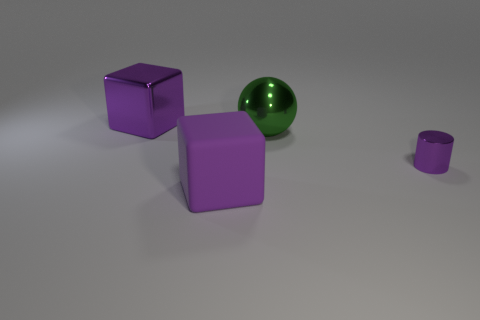Add 3 purple matte cubes. How many objects exist? 7 Subtract all balls. How many objects are left? 3 Add 4 big metallic things. How many big metallic things are left? 6 Add 1 green shiny spheres. How many green shiny spheres exist? 2 Subtract 0 yellow balls. How many objects are left? 4 Subtract all tiny cyan shiny blocks. Subtract all large balls. How many objects are left? 3 